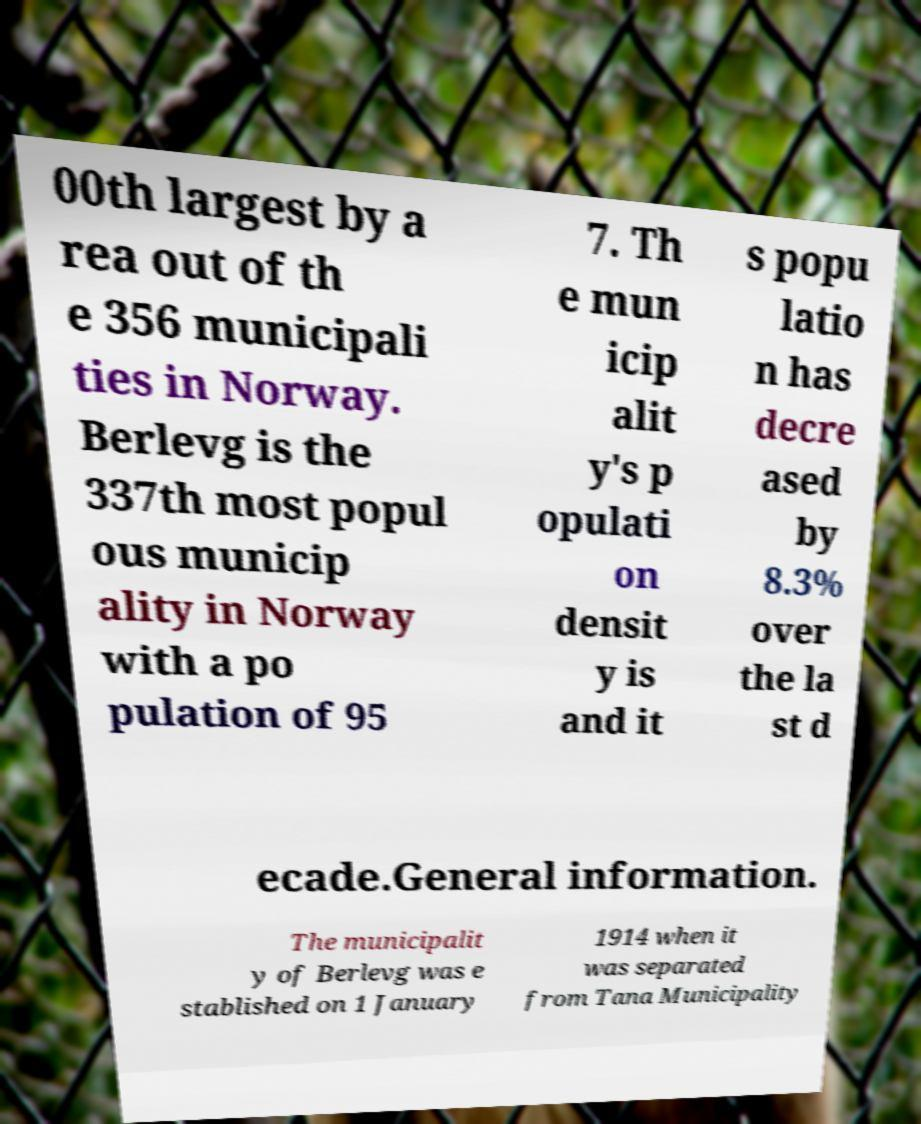Can you read and provide the text displayed in the image?This photo seems to have some interesting text. Can you extract and type it out for me? 00th largest by a rea out of th e 356 municipali ties in Norway. Berlevg is the 337th most popul ous municip ality in Norway with a po pulation of 95 7. Th e mun icip alit y's p opulati on densit y is and it s popu latio n has decre ased by 8.3% over the la st d ecade.General information. The municipalit y of Berlevg was e stablished on 1 January 1914 when it was separated from Tana Municipality 